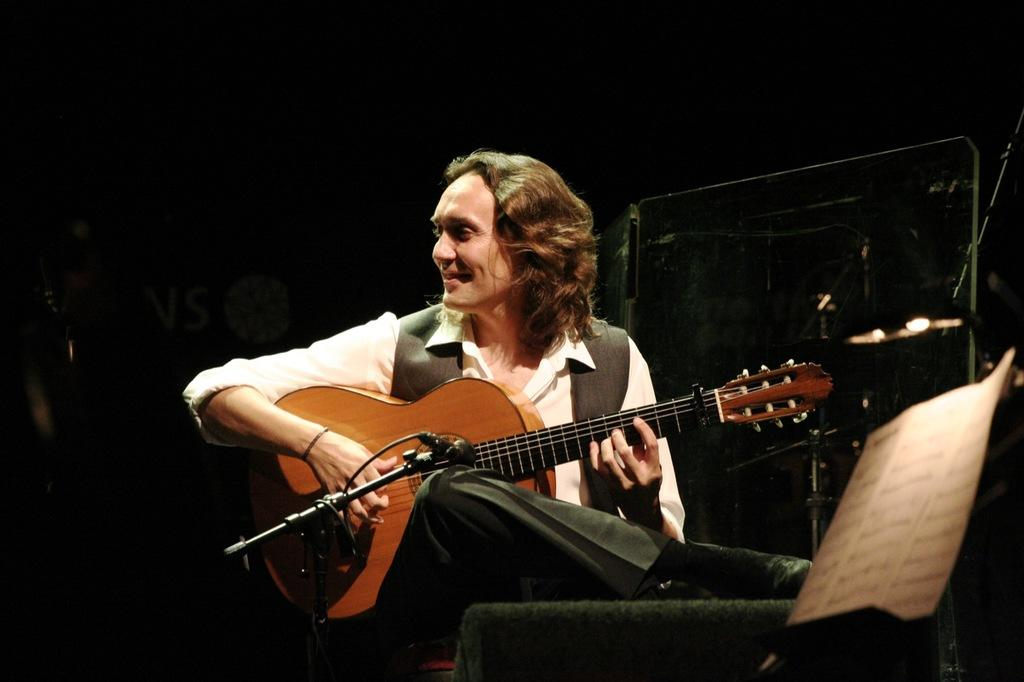What is the man in the image doing? The man is sitting in the image. What is the man holding in the image? The man is holding a yellow-colored music instrument. Can you describe another object in the image related to music? There is a black-colored microphone in the image. What type of pig can be seen participating in the discussion in the image? There is no pig or discussion present in the image. 